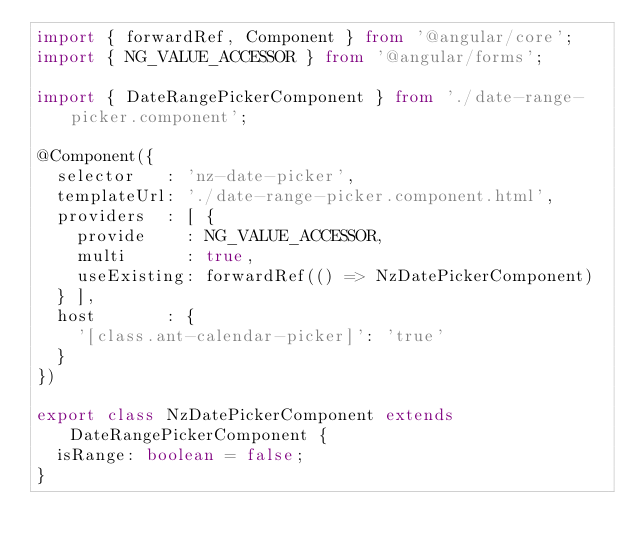<code> <loc_0><loc_0><loc_500><loc_500><_TypeScript_>import { forwardRef, Component } from '@angular/core';
import { NG_VALUE_ACCESSOR } from '@angular/forms';

import { DateRangePickerComponent } from './date-range-picker.component';

@Component({
  selector   : 'nz-date-picker',
  templateUrl: './date-range-picker.component.html',
  providers  : [ {
    provide    : NG_VALUE_ACCESSOR,
    multi      : true,
    useExisting: forwardRef(() => NzDatePickerComponent)
  } ],
  host       : {
    '[class.ant-calendar-picker]': 'true'
  }
})

export class NzDatePickerComponent extends DateRangePickerComponent {
  isRange: boolean = false;
}
</code> 